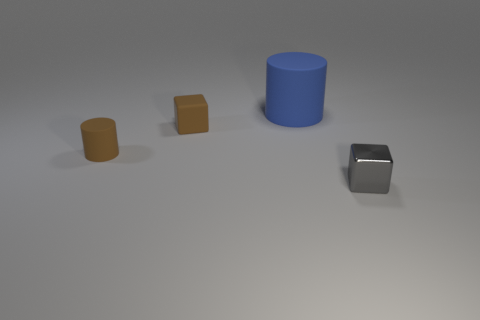The tiny matte thing that is the same color as the tiny rubber cube is what shape?
Offer a very short reply. Cylinder. What number of balls are brown things or large blue matte things?
Your response must be concise. 0. There is a tiny matte object that is in front of the block on the left side of the large blue cylinder; what color is it?
Provide a short and direct response. Brown. There is a big object; is its color the same as the tiny block that is to the right of the blue rubber object?
Ensure brevity in your answer.  No. What is the size of the brown cube that is made of the same material as the big thing?
Offer a terse response. Small. The matte block that is the same color as the tiny rubber cylinder is what size?
Provide a succinct answer. Small. Do the small matte cube and the metallic thing have the same color?
Ensure brevity in your answer.  No. Is there a gray metal thing on the right side of the tiny cube right of the small block left of the gray object?
Provide a short and direct response. No. How many blocks have the same size as the gray thing?
Your response must be concise. 1. Is the size of the cylinder in front of the blue thing the same as the block to the left of the large rubber object?
Ensure brevity in your answer.  Yes. 